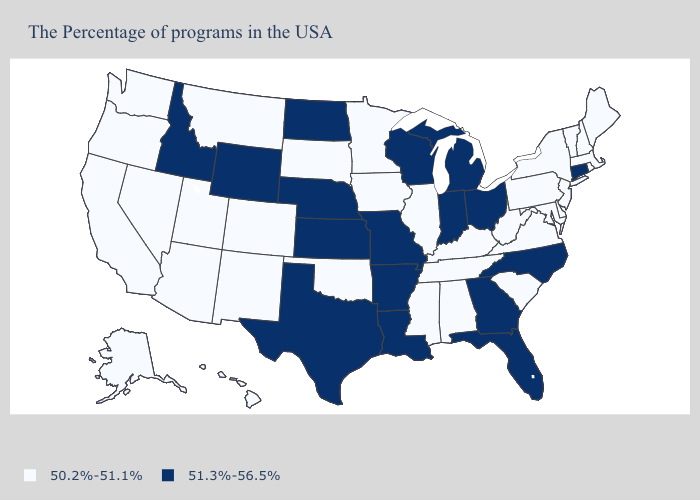What is the value of Rhode Island?
Answer briefly. 50.2%-51.1%. What is the lowest value in the Northeast?
Quick response, please. 50.2%-51.1%. Does the first symbol in the legend represent the smallest category?
Short answer required. Yes. What is the lowest value in the USA?
Answer briefly. 50.2%-51.1%. Among the states that border Wisconsin , which have the highest value?
Write a very short answer. Michigan. Name the states that have a value in the range 51.3%-56.5%?
Be succinct. Connecticut, North Carolina, Ohio, Florida, Georgia, Michigan, Indiana, Wisconsin, Louisiana, Missouri, Arkansas, Kansas, Nebraska, Texas, North Dakota, Wyoming, Idaho. Name the states that have a value in the range 50.2%-51.1%?
Answer briefly. Maine, Massachusetts, Rhode Island, New Hampshire, Vermont, New York, New Jersey, Delaware, Maryland, Pennsylvania, Virginia, South Carolina, West Virginia, Kentucky, Alabama, Tennessee, Illinois, Mississippi, Minnesota, Iowa, Oklahoma, South Dakota, Colorado, New Mexico, Utah, Montana, Arizona, Nevada, California, Washington, Oregon, Alaska, Hawaii. What is the lowest value in the USA?
Keep it brief. 50.2%-51.1%. What is the value of Colorado?
Write a very short answer. 50.2%-51.1%. What is the lowest value in the Northeast?
Be succinct. 50.2%-51.1%. Which states have the lowest value in the USA?
Give a very brief answer. Maine, Massachusetts, Rhode Island, New Hampshire, Vermont, New York, New Jersey, Delaware, Maryland, Pennsylvania, Virginia, South Carolina, West Virginia, Kentucky, Alabama, Tennessee, Illinois, Mississippi, Minnesota, Iowa, Oklahoma, South Dakota, Colorado, New Mexico, Utah, Montana, Arizona, Nevada, California, Washington, Oregon, Alaska, Hawaii. Name the states that have a value in the range 51.3%-56.5%?
Write a very short answer. Connecticut, North Carolina, Ohio, Florida, Georgia, Michigan, Indiana, Wisconsin, Louisiana, Missouri, Arkansas, Kansas, Nebraska, Texas, North Dakota, Wyoming, Idaho. Which states have the lowest value in the USA?
Quick response, please. Maine, Massachusetts, Rhode Island, New Hampshire, Vermont, New York, New Jersey, Delaware, Maryland, Pennsylvania, Virginia, South Carolina, West Virginia, Kentucky, Alabama, Tennessee, Illinois, Mississippi, Minnesota, Iowa, Oklahoma, South Dakota, Colorado, New Mexico, Utah, Montana, Arizona, Nevada, California, Washington, Oregon, Alaska, Hawaii. How many symbols are there in the legend?
Quick response, please. 2. 